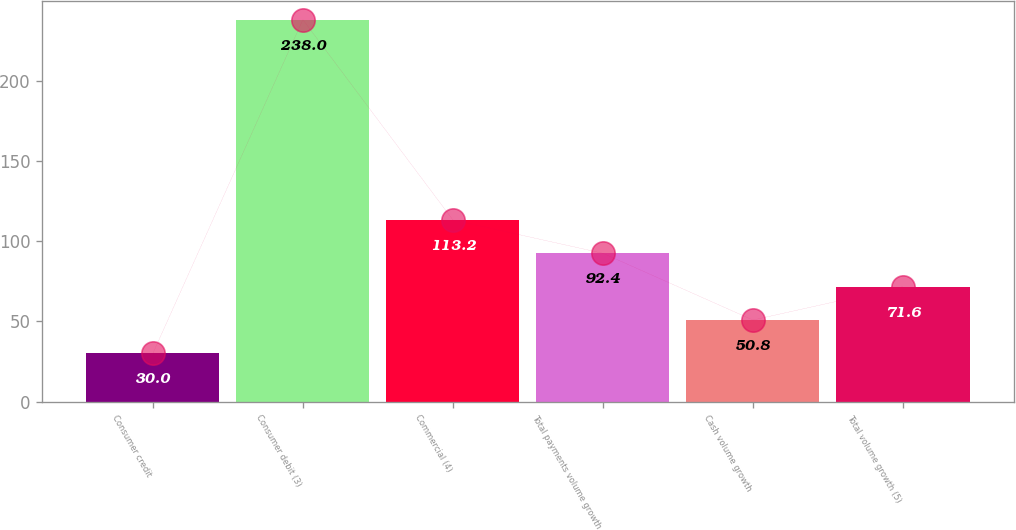<chart> <loc_0><loc_0><loc_500><loc_500><bar_chart><fcel>Consumer credit<fcel>Consumer debit (3)<fcel>Commercial (4)<fcel>Total payments volume growth<fcel>Cash volume growth<fcel>Total volume growth (5)<nl><fcel>30<fcel>238<fcel>113.2<fcel>92.4<fcel>50.8<fcel>71.6<nl></chart> 